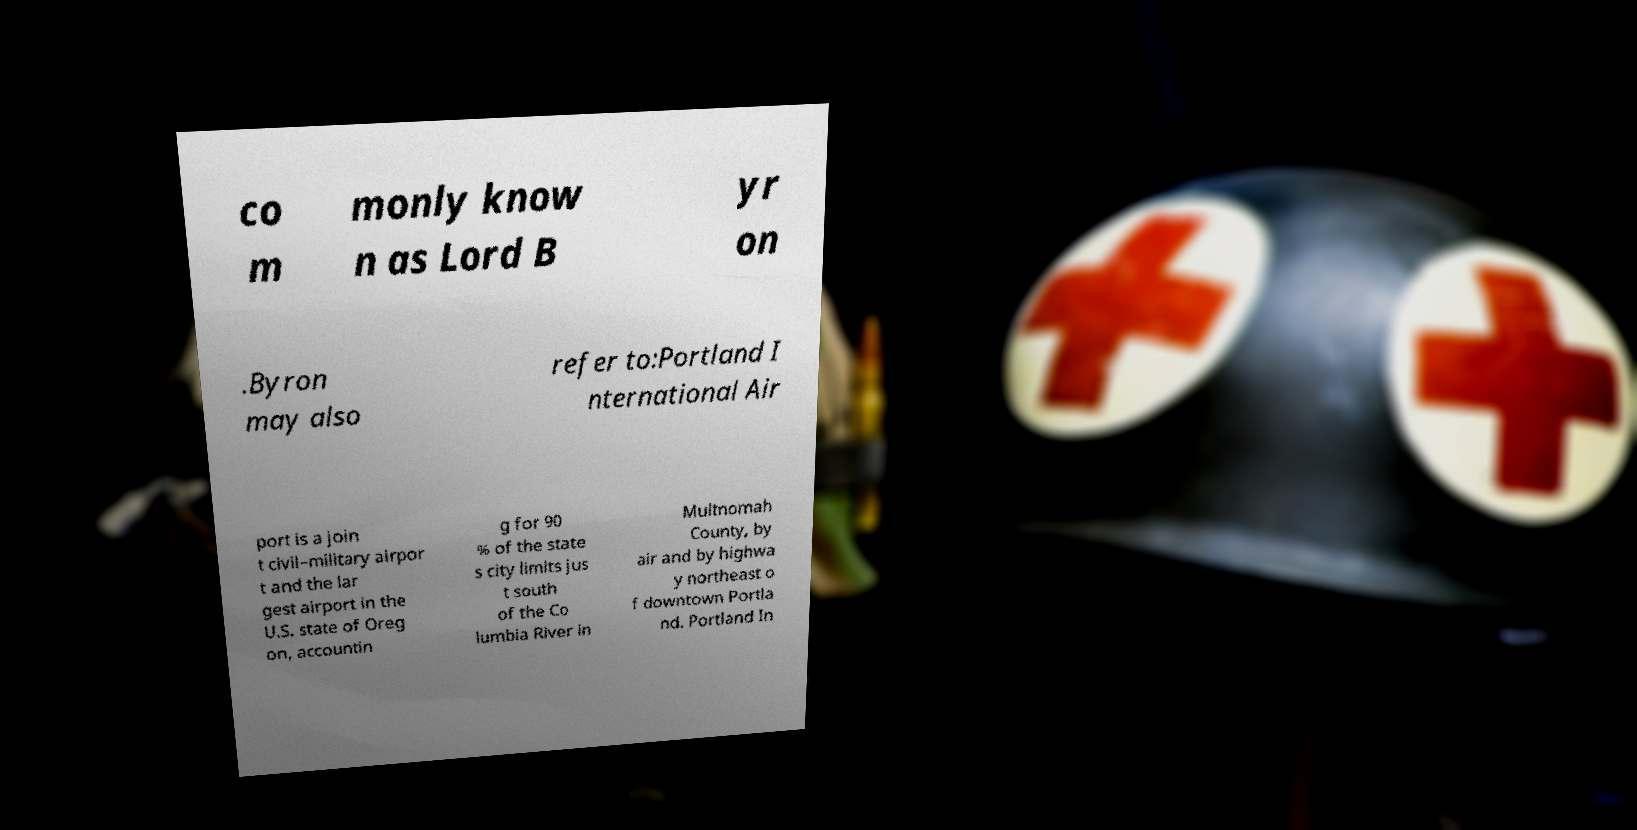There's text embedded in this image that I need extracted. Can you transcribe it verbatim? co m monly know n as Lord B yr on .Byron may also refer to:Portland I nternational Air port is a join t civil–military airpor t and the lar gest airport in the U.S. state of Oreg on, accountin g for 90 % of the state s city limits jus t south of the Co lumbia River in Multnomah County, by air and by highwa y northeast o f downtown Portla nd. Portland In 